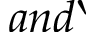Convert formula to latex. <formula><loc_0><loc_0><loc_500><loc_500>a n d `</formula> 